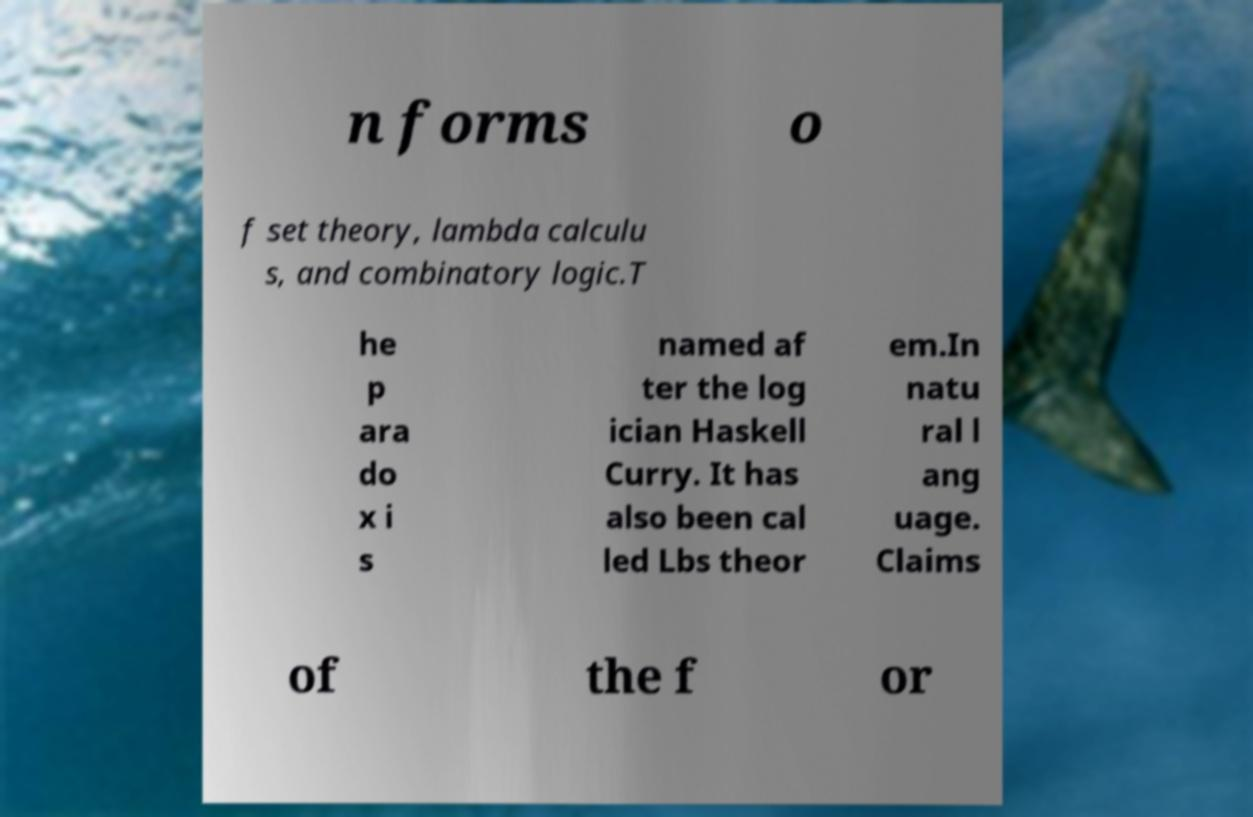Please read and relay the text visible in this image. What does it say? n forms o f set theory, lambda calculu s, and combinatory logic.T he p ara do x i s named af ter the log ician Haskell Curry. It has also been cal led Lbs theor em.In natu ral l ang uage. Claims of the f or 